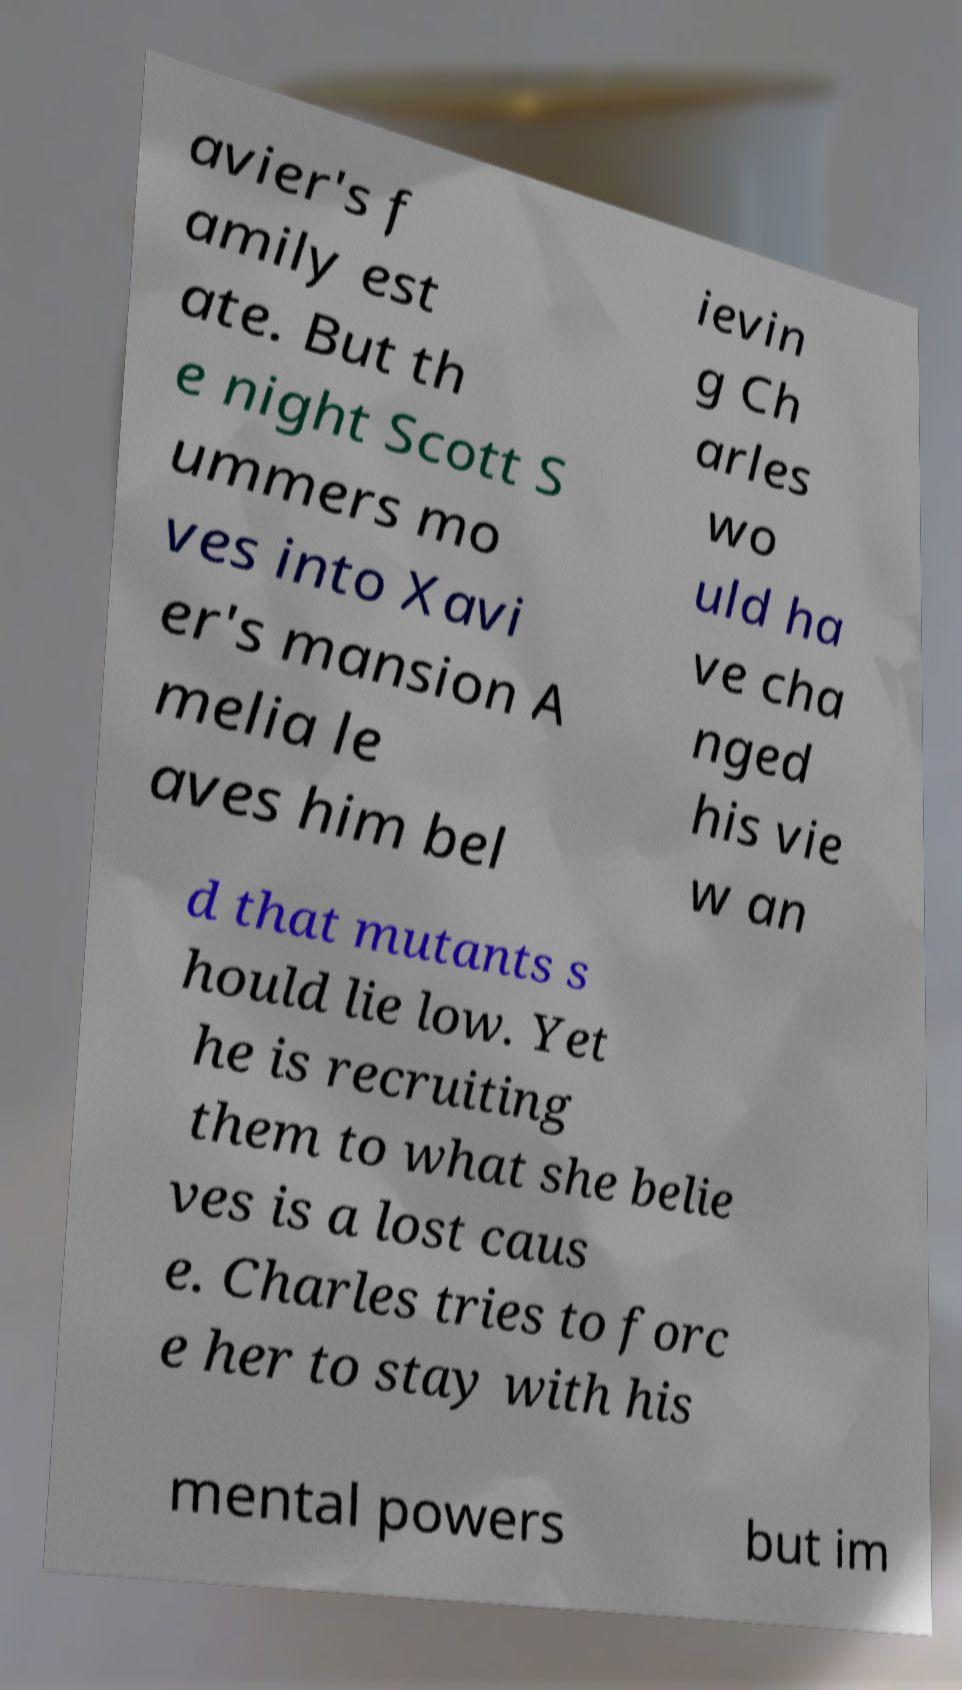I need the written content from this picture converted into text. Can you do that? avier's f amily est ate. But th e night Scott S ummers mo ves into Xavi er's mansion A melia le aves him bel ievin g Ch arles wo uld ha ve cha nged his vie w an d that mutants s hould lie low. Yet he is recruiting them to what she belie ves is a lost caus e. Charles tries to forc e her to stay with his mental powers but im 